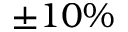<formula> <loc_0><loc_0><loc_500><loc_500>\pm 1 0 \%</formula> 